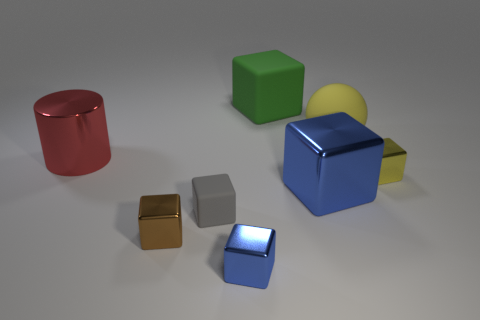Subtract all metal cubes. How many cubes are left? 2 Add 2 large yellow balls. How many objects exist? 10 Subtract all balls. How many objects are left? 7 Subtract all blue blocks. How many blocks are left? 4 Subtract 5 blocks. How many blocks are left? 1 Add 1 red shiny objects. How many red shiny objects are left? 2 Add 8 large green objects. How many large green objects exist? 9 Subtract 0 blue cylinders. How many objects are left? 8 Subtract all yellow cubes. Subtract all yellow spheres. How many cubes are left? 5 Subtract all cyan cylinders. How many green cubes are left? 1 